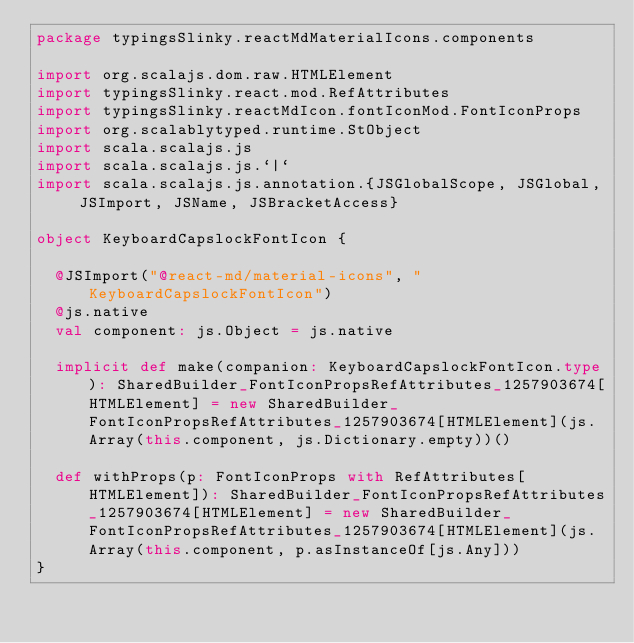<code> <loc_0><loc_0><loc_500><loc_500><_Scala_>package typingsSlinky.reactMdMaterialIcons.components

import org.scalajs.dom.raw.HTMLElement
import typingsSlinky.react.mod.RefAttributes
import typingsSlinky.reactMdIcon.fontIconMod.FontIconProps
import org.scalablytyped.runtime.StObject
import scala.scalajs.js
import scala.scalajs.js.`|`
import scala.scalajs.js.annotation.{JSGlobalScope, JSGlobal, JSImport, JSName, JSBracketAccess}

object KeyboardCapslockFontIcon {
  
  @JSImport("@react-md/material-icons", "KeyboardCapslockFontIcon")
  @js.native
  val component: js.Object = js.native
  
  implicit def make(companion: KeyboardCapslockFontIcon.type): SharedBuilder_FontIconPropsRefAttributes_1257903674[HTMLElement] = new SharedBuilder_FontIconPropsRefAttributes_1257903674[HTMLElement](js.Array(this.component, js.Dictionary.empty))()
  
  def withProps(p: FontIconProps with RefAttributes[HTMLElement]): SharedBuilder_FontIconPropsRefAttributes_1257903674[HTMLElement] = new SharedBuilder_FontIconPropsRefAttributes_1257903674[HTMLElement](js.Array(this.component, p.asInstanceOf[js.Any]))
}
</code> 